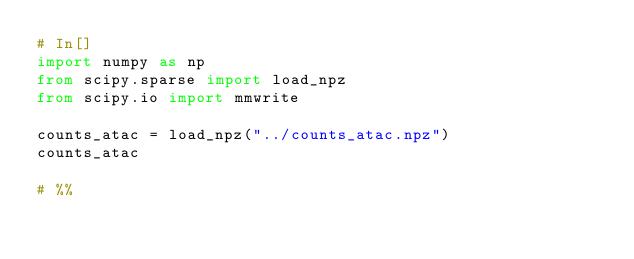<code> <loc_0><loc_0><loc_500><loc_500><_Python_># In[]
import numpy as np 
from scipy.sparse import load_npz
from scipy.io import mmwrite

counts_atac = load_npz("../counts_atac.npz")
counts_atac

# %%
</code> 